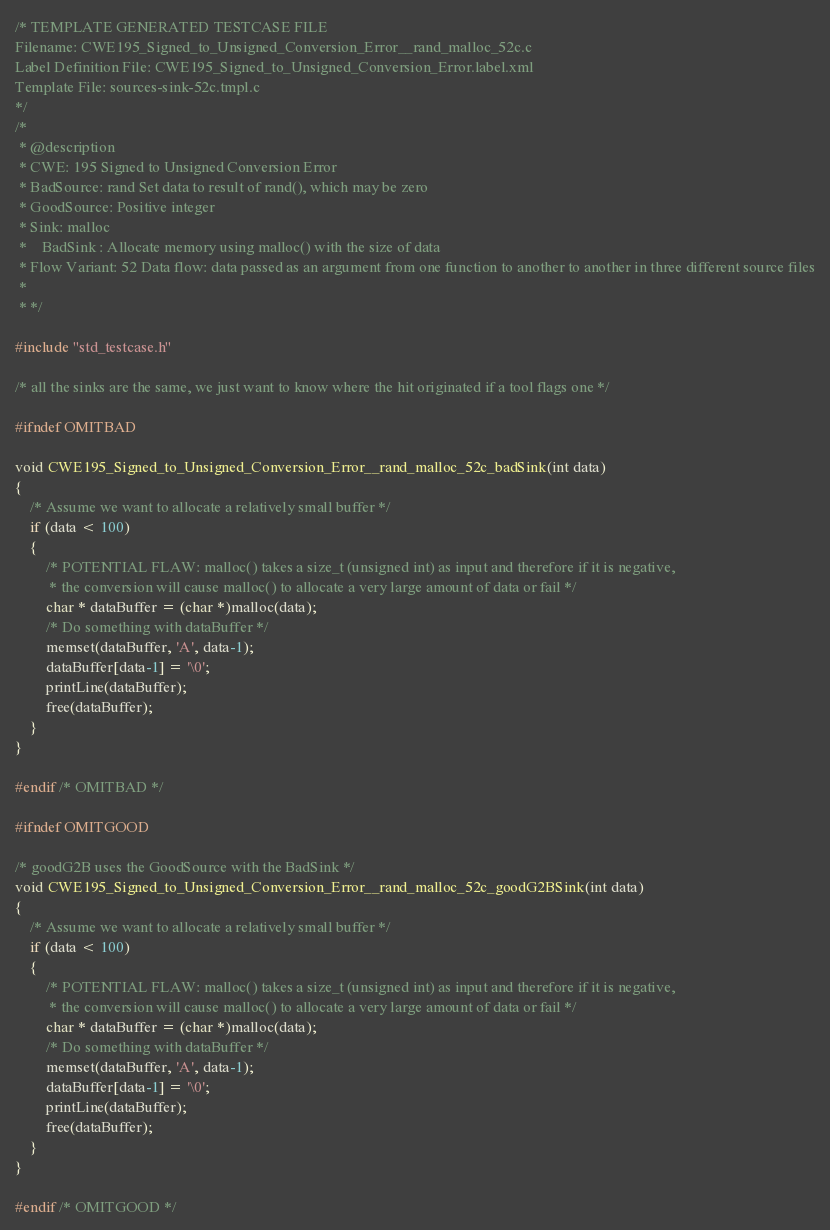Convert code to text. <code><loc_0><loc_0><loc_500><loc_500><_C_>/* TEMPLATE GENERATED TESTCASE FILE
Filename: CWE195_Signed_to_Unsigned_Conversion_Error__rand_malloc_52c.c
Label Definition File: CWE195_Signed_to_Unsigned_Conversion_Error.label.xml
Template File: sources-sink-52c.tmpl.c
*/
/*
 * @description
 * CWE: 195 Signed to Unsigned Conversion Error
 * BadSource: rand Set data to result of rand(), which may be zero
 * GoodSource: Positive integer
 * Sink: malloc
 *    BadSink : Allocate memory using malloc() with the size of data
 * Flow Variant: 52 Data flow: data passed as an argument from one function to another to another in three different source files
 *
 * */

#include "std_testcase.h"

/* all the sinks are the same, we just want to know where the hit originated if a tool flags one */

#ifndef OMITBAD

void CWE195_Signed_to_Unsigned_Conversion_Error__rand_malloc_52c_badSink(int data)
{
    /* Assume we want to allocate a relatively small buffer */
    if (data < 100)
    {
        /* POTENTIAL FLAW: malloc() takes a size_t (unsigned int) as input and therefore if it is negative,
         * the conversion will cause malloc() to allocate a very large amount of data or fail */
        char * dataBuffer = (char *)malloc(data);
        /* Do something with dataBuffer */
        memset(dataBuffer, 'A', data-1);
        dataBuffer[data-1] = '\0';
        printLine(dataBuffer);
        free(dataBuffer);
    }
}

#endif /* OMITBAD */

#ifndef OMITGOOD

/* goodG2B uses the GoodSource with the BadSink */
void CWE195_Signed_to_Unsigned_Conversion_Error__rand_malloc_52c_goodG2BSink(int data)
{
    /* Assume we want to allocate a relatively small buffer */
    if (data < 100)
    {
        /* POTENTIAL FLAW: malloc() takes a size_t (unsigned int) as input and therefore if it is negative,
         * the conversion will cause malloc() to allocate a very large amount of data or fail */
        char * dataBuffer = (char *)malloc(data);
        /* Do something with dataBuffer */
        memset(dataBuffer, 'A', data-1);
        dataBuffer[data-1] = '\0';
        printLine(dataBuffer);
        free(dataBuffer);
    }
}

#endif /* OMITGOOD */
</code> 